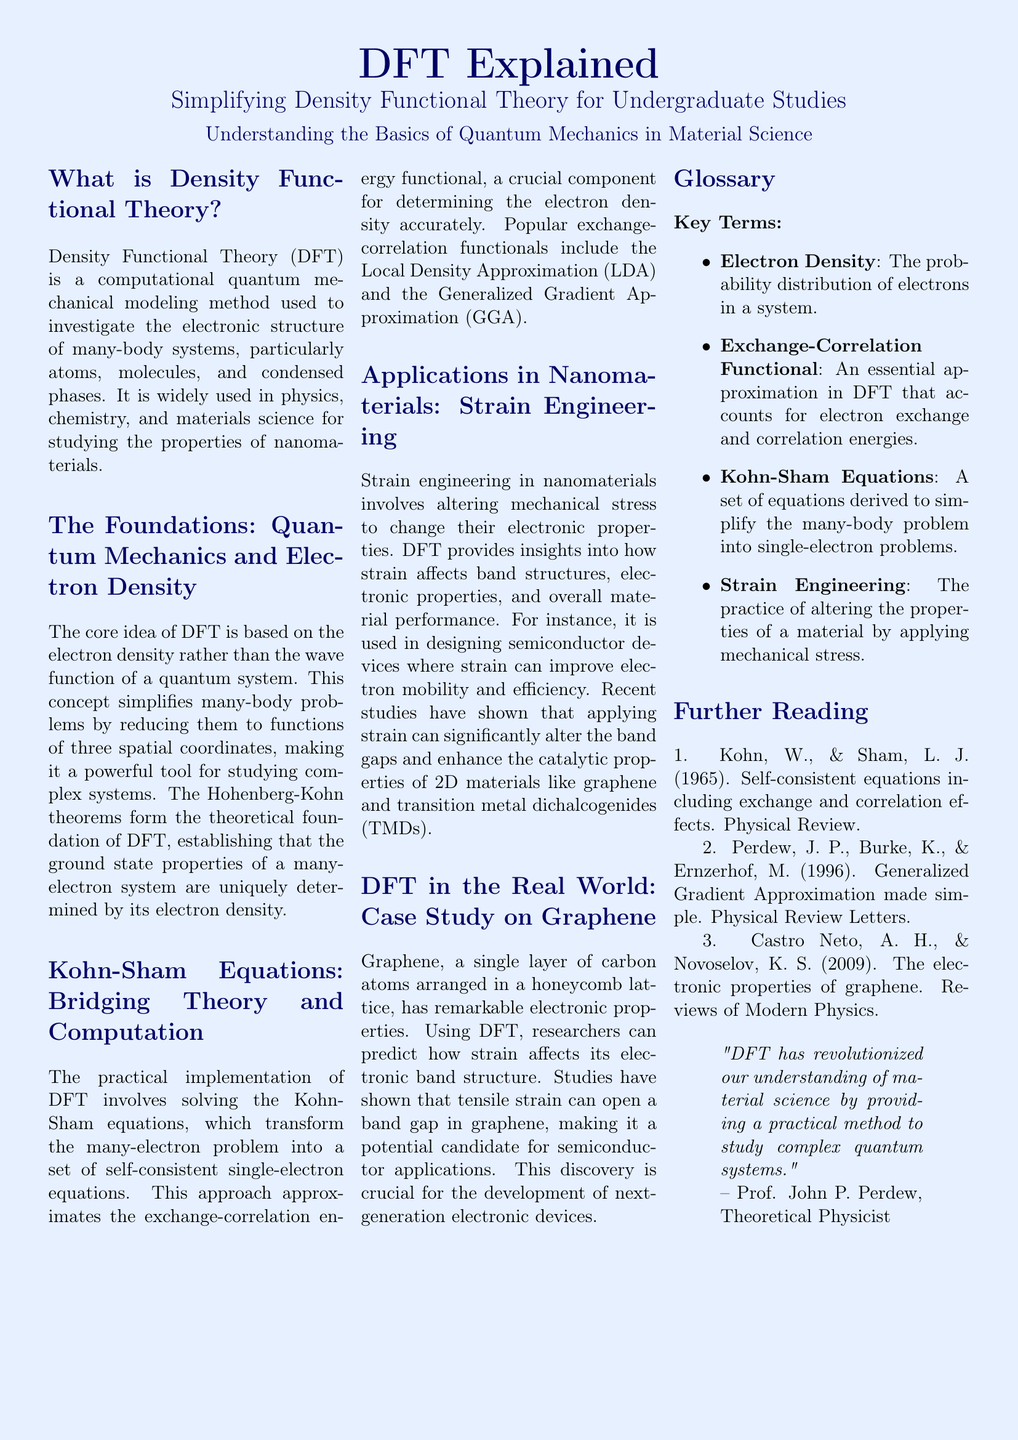What is Density Functional Theory? Density Functional Theory (DFT) is defined in the document as a computational quantum mechanical modeling method used to investigate the electronic structure of many-body systems.
Answer: A computational quantum mechanical modeling method What are the theoretical foundations of DFT? The foundations of DFT are explained as being based on the electron density and the Hohenberg-Kohn theorems, which establish the relationship between electron density and ground state properties.
Answer: Electron density and Hohenberg-Kohn theorems What do Kohn-Sham equations accomplish? The Kohn-Sham equations are described as transforming the many-electron problem into a set of self-consistent single-electron equations.
Answer: Transforming many-electron problems Which materials benefit from strain engineering according to the document? The document mentions specific two-dimensional materials, such as graphene and transition metal dichalcogenides (TMDs), that exhibit changes in properties due to strain.
Answer: Graphene and transition metal dichalcogenides (TMDs) What effect does tensile strain have on graphene? The document states that studies have shown tensile strain can open a band gap in graphene, indicating it impacts its electronic properties.
Answer: Opens a band gap Who authored the foundational paper on self-consistent equations including exchange and correlation effects? The document cites Kohn and Sham as the authors of the foundational paper for DFT.
Answer: Kohn and Sham What is strain engineering? The document defines strain engineering as the practice of altering the properties of a material by applying mechanical stress.
Answer: Altering properties by applying mechanical stress Which approximation is mentioned as popular in DFT? The document mentions Local Density Approximation (LDA) and Generalized Gradient Approximation (GGA) as popular exchange-correlation functionals.
Answer: Local Density Approximation (LDA) and Generalized Gradient Approximation (GGA) What conclusion does Prof. John P. Perdew draw about DFT? The document quotes Prof. John P. Perdew stating that DFT has revolutionized the understanding of material science.
Answer: Revolutionized understanding of material science 